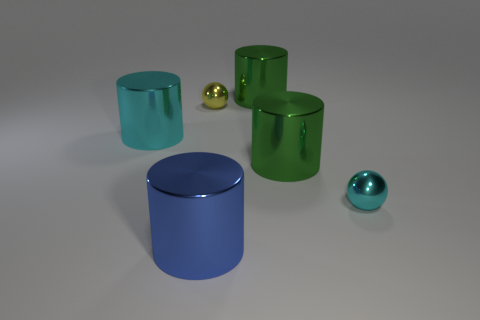There is a blue object that is the same size as the cyan shiny cylinder; what shape is it?
Your answer should be very brief. Cylinder. The yellow shiny ball is what size?
Offer a very short reply. Small. How many cyan metallic things are left of the big shiny thing that is behind the metallic cylinder to the left of the blue object?
Make the answer very short. 1. There is a large green metal object that is in front of the tiny yellow sphere; what shape is it?
Give a very brief answer. Cylinder. What number of other things are made of the same material as the cyan cylinder?
Make the answer very short. 5. Are there fewer cylinders that are in front of the large blue cylinder than tiny yellow things that are on the left side of the small yellow shiny object?
Provide a succinct answer. No. What is the color of the other object that is the same shape as the yellow metallic object?
Keep it short and to the point. Cyan. There is a metallic cylinder that is on the left side of the yellow thing; is its size the same as the yellow metal ball?
Your response must be concise. No. Is the number of tiny spheres behind the tiny cyan object less than the number of big brown rubber cylinders?
Make the answer very short. No. How big is the metallic ball that is to the left of the large green shiny cylinder behind the cyan metallic cylinder?
Keep it short and to the point. Small. 